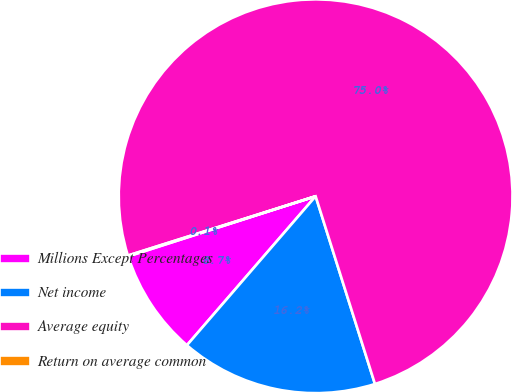<chart> <loc_0><loc_0><loc_500><loc_500><pie_chart><fcel>Millions Except Percentages<fcel>Net income<fcel>Average equity<fcel>Return on average common<nl><fcel>8.72%<fcel>16.21%<fcel>74.99%<fcel>0.07%<nl></chart> 